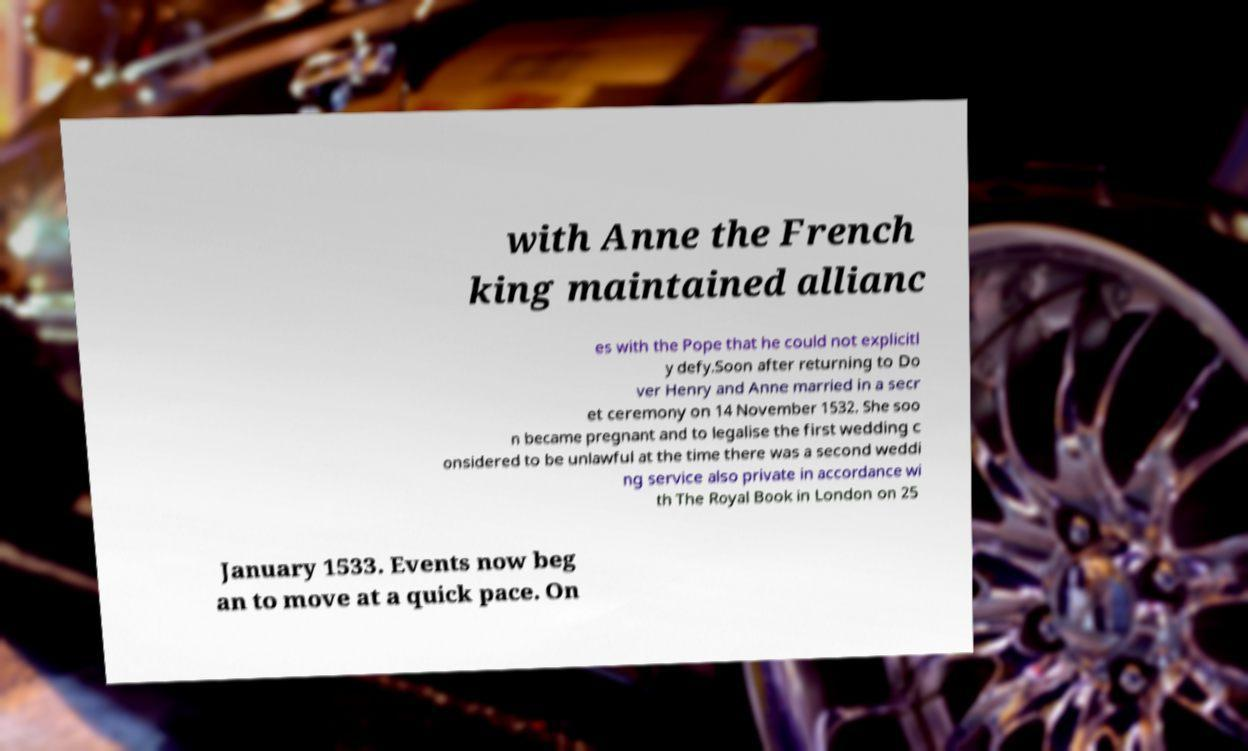For documentation purposes, I need the text within this image transcribed. Could you provide that? with Anne the French king maintained allianc es with the Pope that he could not explicitl y defy.Soon after returning to Do ver Henry and Anne married in a secr et ceremony on 14 November 1532. She soo n became pregnant and to legalise the first wedding c onsidered to be unlawful at the time there was a second weddi ng service also private in accordance wi th The Royal Book in London on 25 January 1533. Events now beg an to move at a quick pace. On 